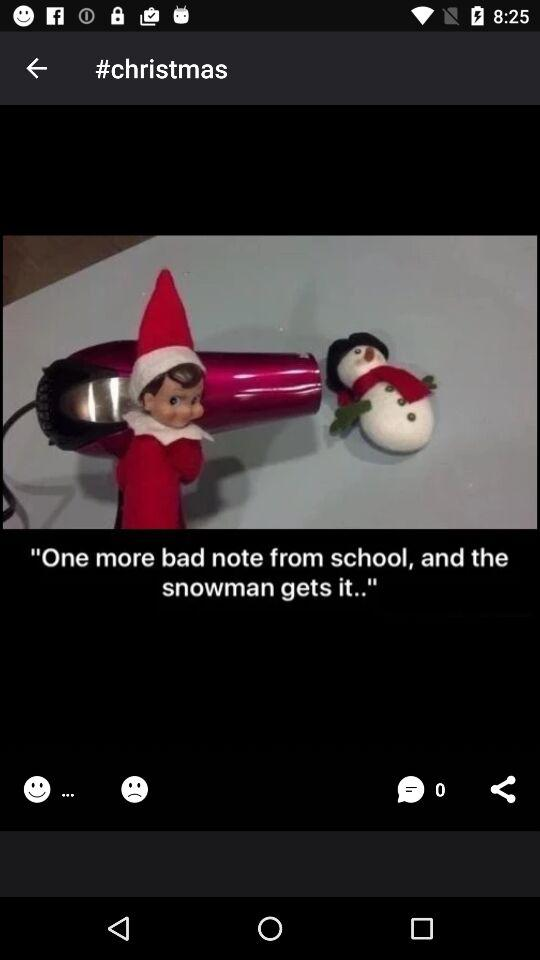How many comments are there? There are 0 comments. 